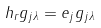Convert formula to latex. <formula><loc_0><loc_0><loc_500><loc_500>h _ { r } g _ { j \lambda } = e _ { j } g _ { j \lambda }</formula> 